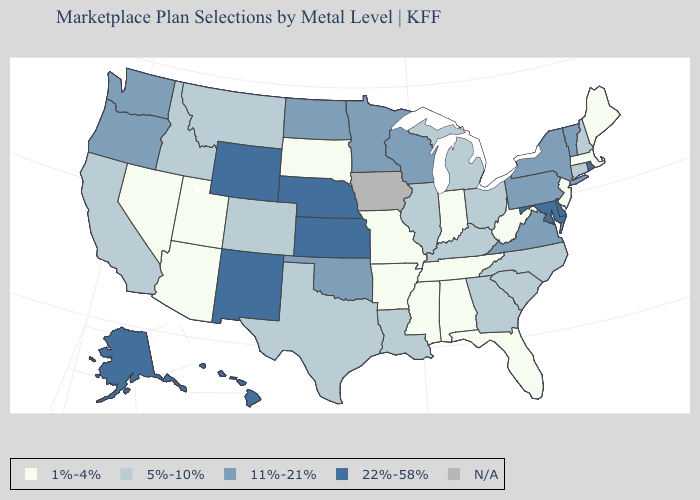Which states have the highest value in the USA?
Be succinct. Alaska, Delaware, Hawaii, Kansas, Maryland, Nebraska, New Mexico, Rhode Island, Wyoming. Does the first symbol in the legend represent the smallest category?
Concise answer only. Yes. What is the highest value in states that border Arizona?
Give a very brief answer. 22%-58%. What is the value of Massachusetts?
Concise answer only. 1%-4%. Does Missouri have the highest value in the USA?
Write a very short answer. No. Does Mississippi have the highest value in the South?
Quick response, please. No. Name the states that have a value in the range 22%-58%?
Short answer required. Alaska, Delaware, Hawaii, Kansas, Maryland, Nebraska, New Mexico, Rhode Island, Wyoming. What is the value of Maryland?
Answer briefly. 22%-58%. What is the lowest value in the South?
Write a very short answer. 1%-4%. Which states hav the highest value in the MidWest?
Be succinct. Kansas, Nebraska. Does the map have missing data?
Quick response, please. Yes. What is the highest value in the West ?
Be succinct. 22%-58%. What is the lowest value in states that border South Dakota?
Give a very brief answer. 5%-10%. What is the value of Kansas?
Quick response, please. 22%-58%. 